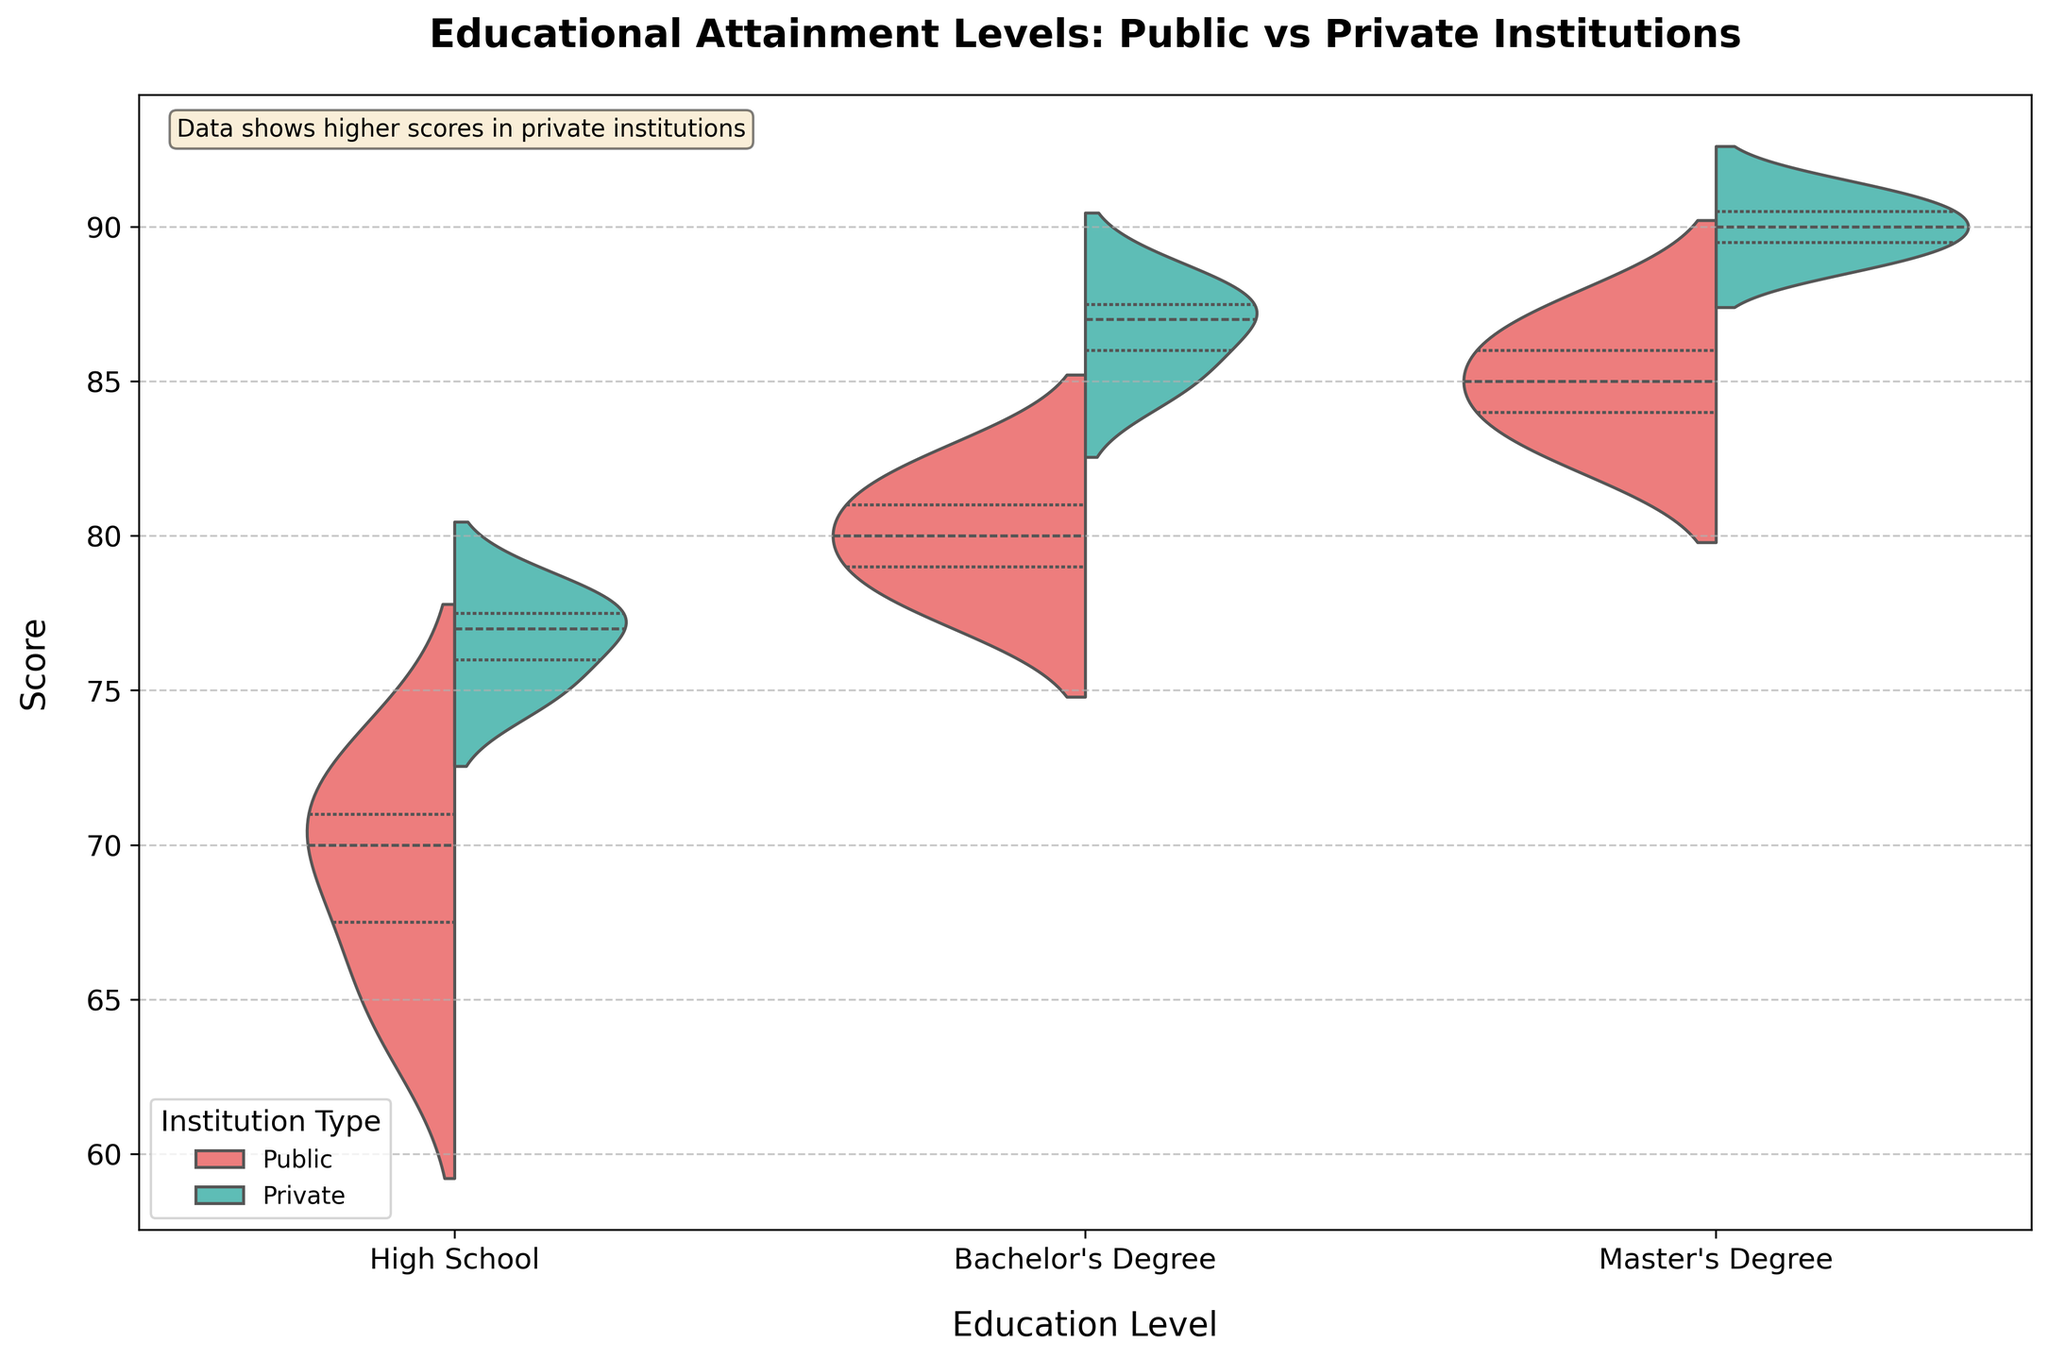What is the title of the chart? The title of the chart is located at the top and it reads "Educational Attainment Levels: Public vs Private Institutions".
Answer: Educational Attainment Levels: Public vs Private Institutions Which education level has the highest scores in both public and private institutions? By looking at the chart, the Master’s Degree level has the highest scores in both public and private institutions.
Answer: Master’s Degree How are the scores distributed for Bachelor's Degree in both public and private institutions in the chart? In the chart, scores for Bachelor's Degree appear to be higher in private institutions compared to public institutions. The private scores seem to center around 85-88, while public scores center around 78-82.
Answer: Higher in private institutions What is the difference between the highest scores for Master’s Degree in private and public institutions? For Master’s Degree, the highest score for private institutions is shown to be around 91 and for public institutions, it is around 87. Subtracting 87 from 91 gives us the difference.
Answer: 4 Which institution type shows a greater range of scores for High School education? Observing the spread of scores for High School education, private institutions show a greater range as their scores stretch from about 75 to 78, whereas public institutions range from about 65 to 72.
Answer: Private institutions How does the median score for Public Bachelor's Degrees compare to Private Bachelor's Degrees? The median score for Public Bachelor's Degrees is approximately around 80 which is lower compared to the median score for Private Bachelor's Degrees, which is around 87.
Answer: Public is lower than Private What insight is provided by the text annotation within the chart? The text annotation at the top left of the chart states "Data shows higher scores in private institutions", indicating that overall, private institutions have higher scores compared to public ones.
Answer: Higher scores in private institutions Are the scores for High School education higher in public or private institutions? The scores for High School education are higher in private institutions as seen by the violin plot showing a higher range of scores for private institutions compared to public institutions.
Answer: Private institutions Considering all education levels, which institution type generally performs better? Looking at the distribution of scores, private institutions generally perform better across all education levels as their scores are consistently higher than those of public institutions.
Answer: Private institutions 